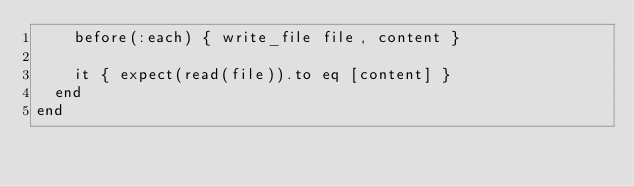Convert code to text. <code><loc_0><loc_0><loc_500><loc_500><_Ruby_>    before(:each) { write_file file, content }

    it { expect(read(file)).to eq [content] }
  end
end
</code> 